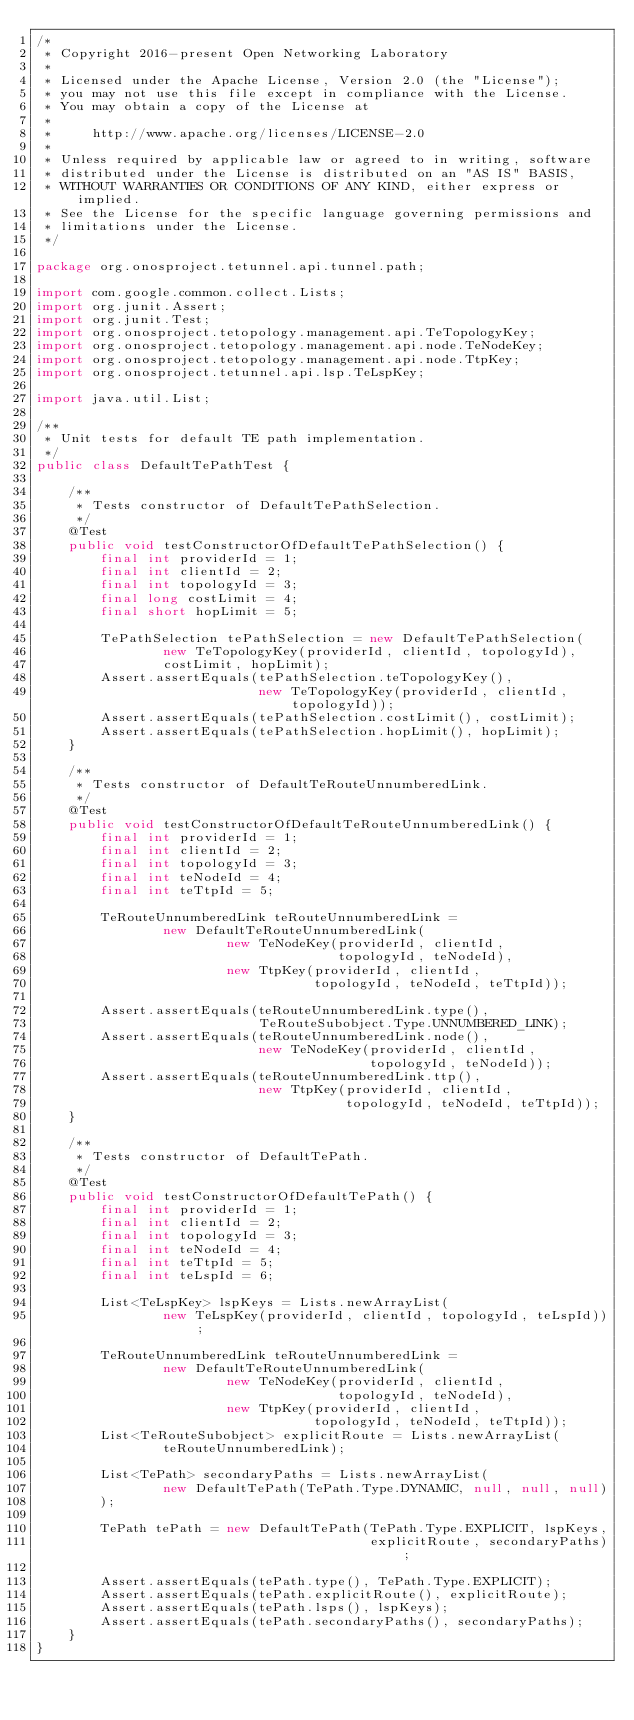Convert code to text. <code><loc_0><loc_0><loc_500><loc_500><_Java_>/*
 * Copyright 2016-present Open Networking Laboratory
 *
 * Licensed under the Apache License, Version 2.0 (the "License");
 * you may not use this file except in compliance with the License.
 * You may obtain a copy of the License at
 *
 *     http://www.apache.org/licenses/LICENSE-2.0
 *
 * Unless required by applicable law or agreed to in writing, software
 * distributed under the License is distributed on an "AS IS" BASIS,
 * WITHOUT WARRANTIES OR CONDITIONS OF ANY KIND, either express or implied.
 * See the License for the specific language governing permissions and
 * limitations under the License.
 */

package org.onosproject.tetunnel.api.tunnel.path;

import com.google.common.collect.Lists;
import org.junit.Assert;
import org.junit.Test;
import org.onosproject.tetopology.management.api.TeTopologyKey;
import org.onosproject.tetopology.management.api.node.TeNodeKey;
import org.onosproject.tetopology.management.api.node.TtpKey;
import org.onosproject.tetunnel.api.lsp.TeLspKey;

import java.util.List;

/**
 * Unit tests for default TE path implementation.
 */
public class DefaultTePathTest {

    /**
     * Tests constructor of DefaultTePathSelection.
     */
    @Test
    public void testConstructorOfDefaultTePathSelection() {
        final int providerId = 1;
        final int clientId = 2;
        final int topologyId = 3;
        final long costLimit = 4;
        final short hopLimit = 5;

        TePathSelection tePathSelection = new DefaultTePathSelection(
                new TeTopologyKey(providerId, clientId, topologyId),
                costLimit, hopLimit);
        Assert.assertEquals(tePathSelection.teTopologyKey(),
                            new TeTopologyKey(providerId, clientId, topologyId));
        Assert.assertEquals(tePathSelection.costLimit(), costLimit);
        Assert.assertEquals(tePathSelection.hopLimit(), hopLimit);
    }

    /**
     * Tests constructor of DefaultTeRouteUnnumberedLink.
     */
    @Test
    public void testConstructorOfDefaultTeRouteUnnumberedLink() {
        final int providerId = 1;
        final int clientId = 2;
        final int topologyId = 3;
        final int teNodeId = 4;
        final int teTtpId = 5;

        TeRouteUnnumberedLink teRouteUnnumberedLink =
                new DefaultTeRouteUnnumberedLink(
                        new TeNodeKey(providerId, clientId,
                                      topologyId, teNodeId),
                        new TtpKey(providerId, clientId,
                                   topologyId, teNodeId, teTtpId));

        Assert.assertEquals(teRouteUnnumberedLink.type(),
                            TeRouteSubobject.Type.UNNUMBERED_LINK);
        Assert.assertEquals(teRouteUnnumberedLink.node(),
                            new TeNodeKey(providerId, clientId,
                                          topologyId, teNodeId));
        Assert.assertEquals(teRouteUnnumberedLink.ttp(),
                            new TtpKey(providerId, clientId,
                                       topologyId, teNodeId, teTtpId));
    }

    /**
     * Tests constructor of DefaultTePath.
     */
    @Test
    public void testConstructorOfDefaultTePath() {
        final int providerId = 1;
        final int clientId = 2;
        final int topologyId = 3;
        final int teNodeId = 4;
        final int teTtpId = 5;
        final int teLspId = 6;

        List<TeLspKey> lspKeys = Lists.newArrayList(
                new TeLspKey(providerId, clientId, topologyId, teLspId));

        TeRouteUnnumberedLink teRouteUnnumberedLink =
                new DefaultTeRouteUnnumberedLink(
                        new TeNodeKey(providerId, clientId,
                                      topologyId, teNodeId),
                        new TtpKey(providerId, clientId,
                                   topologyId, teNodeId, teTtpId));
        List<TeRouteSubobject> explicitRoute = Lists.newArrayList(
                teRouteUnnumberedLink);

        List<TePath> secondaryPaths = Lists.newArrayList(
                new DefaultTePath(TePath.Type.DYNAMIC, null, null, null)
        );

        TePath tePath = new DefaultTePath(TePath.Type.EXPLICIT, lspKeys,
                                          explicitRoute, secondaryPaths);

        Assert.assertEquals(tePath.type(), TePath.Type.EXPLICIT);
        Assert.assertEquals(tePath.explicitRoute(), explicitRoute);
        Assert.assertEquals(tePath.lsps(), lspKeys);
        Assert.assertEquals(tePath.secondaryPaths(), secondaryPaths);
    }
}
</code> 